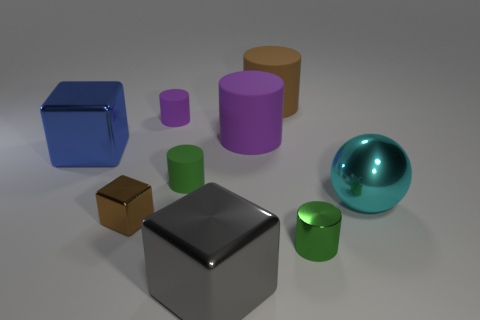Does the green cylinder to the left of the gray cube have the same size as the small green metal object?
Ensure brevity in your answer.  Yes. What number of other objects are the same color as the sphere?
Your answer should be very brief. 0. What is the big blue cube made of?
Offer a very short reply. Metal. The tiny object that is both in front of the big ball and to the right of the small purple rubber cylinder is made of what material?
Your answer should be compact. Metal. What number of things are either big objects that are to the right of the blue block or brown cylinders?
Offer a terse response. 4. Does the big metallic ball have the same color as the small cube?
Ensure brevity in your answer.  No. Is there a green shiny cylinder of the same size as the green matte thing?
Make the answer very short. Yes. What number of metallic things are on the left side of the big ball and behind the small green shiny cylinder?
Offer a very short reply. 2. What number of green shiny objects are left of the blue metal object?
Your answer should be very brief. 0. Are there any purple things of the same shape as the cyan object?
Make the answer very short. No. 